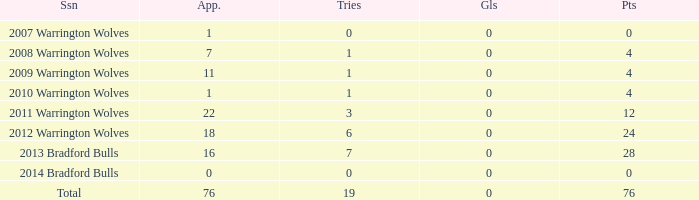What is the lowest appearance when goals is more than 0? None. 